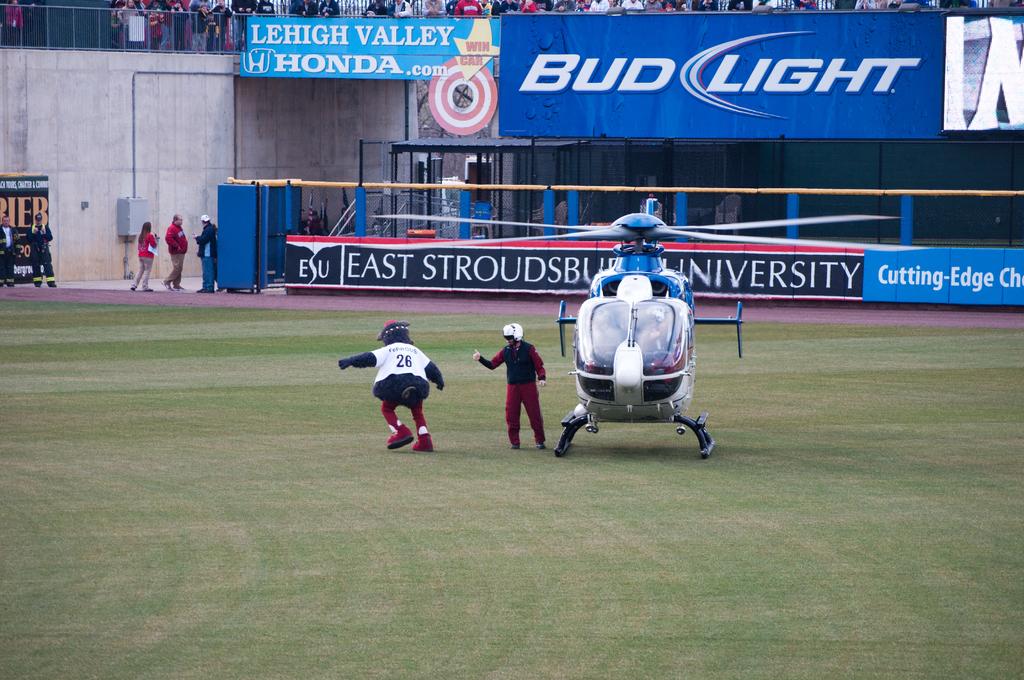What beer sign is that?
Provide a short and direct response. Bud light. What car brand is in the photo?
Make the answer very short. Honda. 